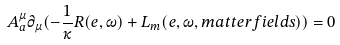Convert formula to latex. <formula><loc_0><loc_0><loc_500><loc_500>A _ { a } ^ { \mu } \partial _ { \mu } ( - \frac { 1 } { \kappa } R ( e , \omega ) + L _ { m } ( e , \omega , m a t t e r f i e l d s ) ) = 0</formula> 